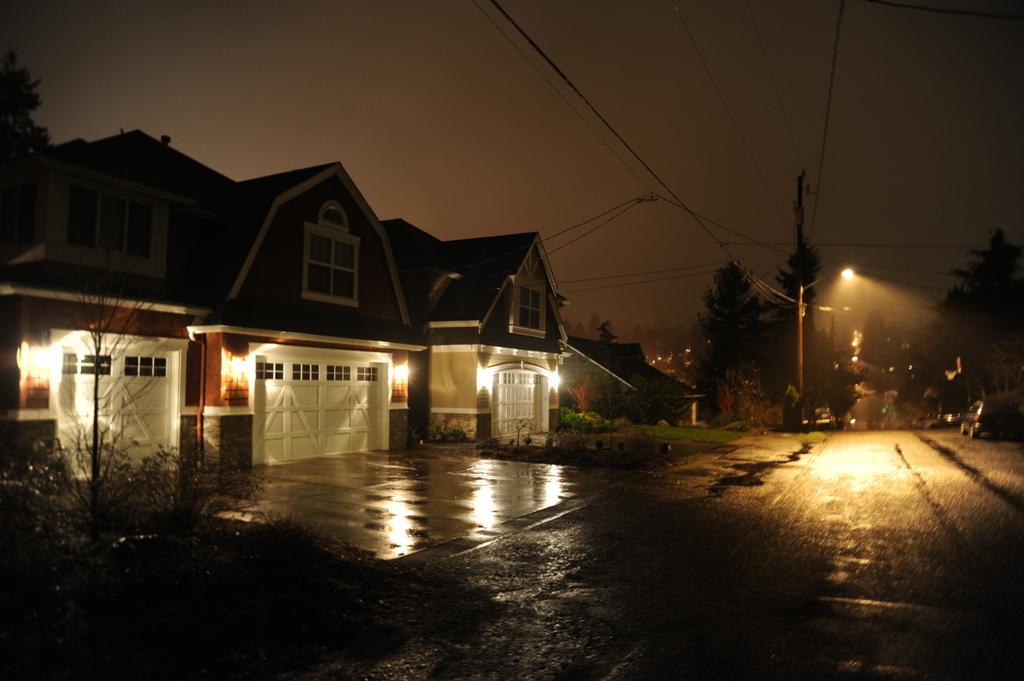Describe this image in one or two sentences. In this image there is a road at the bottom. There are buildings and trees in the left corner. There are vehicles and trees in the right corner. There are trees in the background. And the sky is dark at the top. 